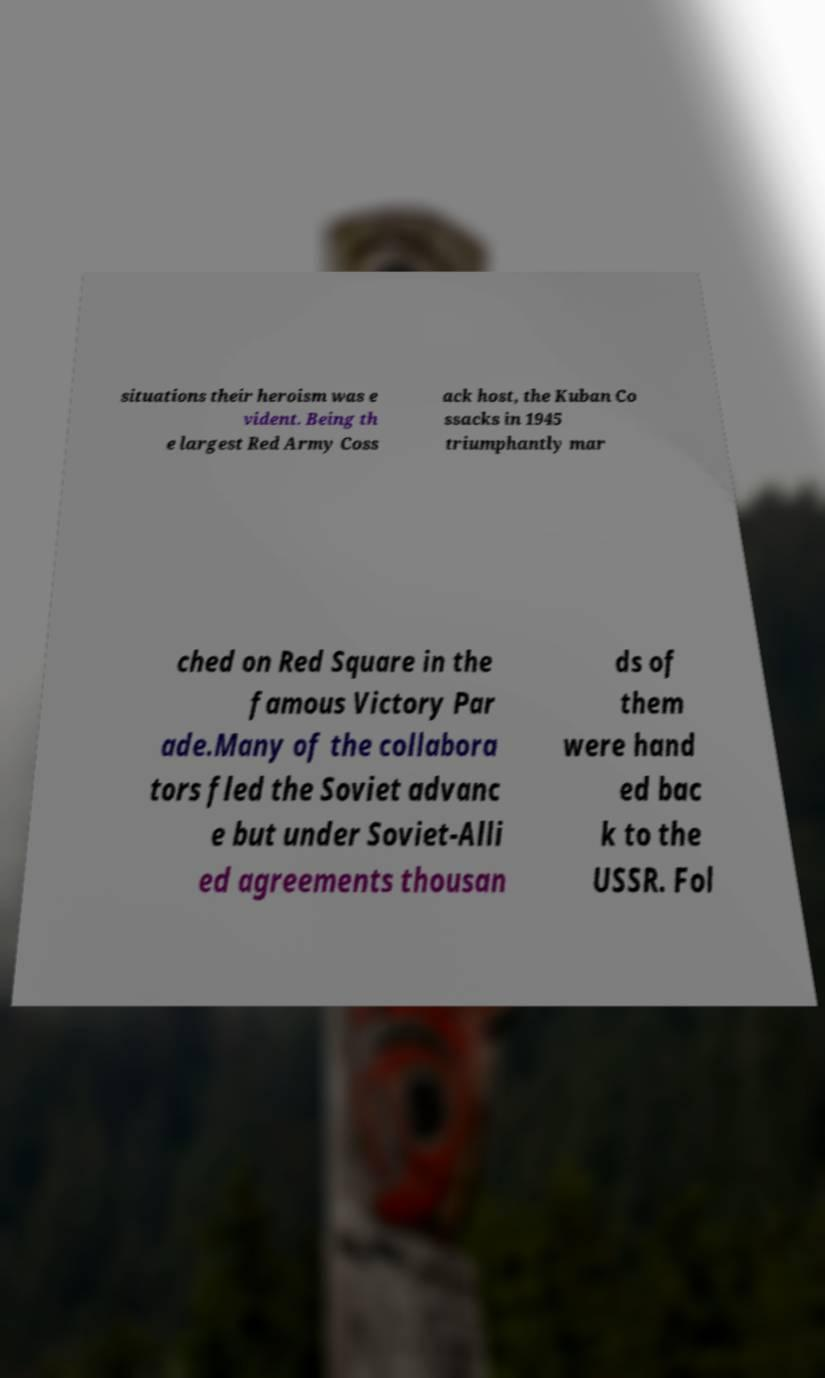I need the written content from this picture converted into text. Can you do that? situations their heroism was e vident. Being th e largest Red Army Coss ack host, the Kuban Co ssacks in 1945 triumphantly mar ched on Red Square in the famous Victory Par ade.Many of the collabora tors fled the Soviet advanc e but under Soviet-Alli ed agreements thousan ds of them were hand ed bac k to the USSR. Fol 